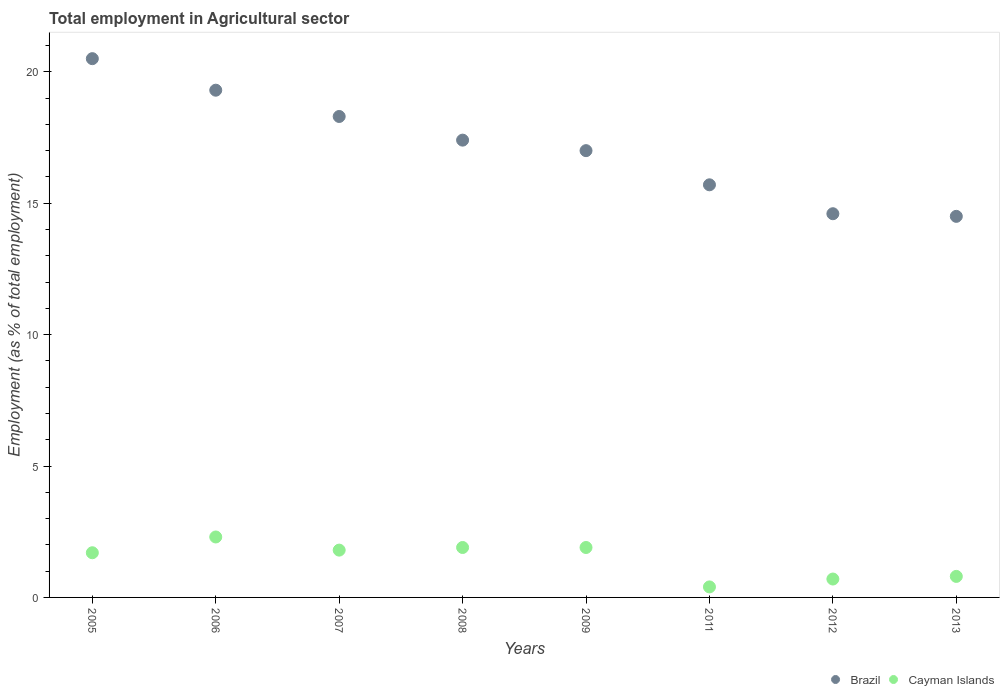How many different coloured dotlines are there?
Your answer should be very brief. 2. Is the number of dotlines equal to the number of legend labels?
Provide a short and direct response. Yes. What is the employment in agricultural sector in Cayman Islands in 2011?
Provide a short and direct response. 0.4. Across all years, what is the maximum employment in agricultural sector in Cayman Islands?
Your answer should be compact. 2.3. What is the total employment in agricultural sector in Brazil in the graph?
Give a very brief answer. 137.3. What is the difference between the employment in agricultural sector in Brazil in 2008 and that in 2013?
Provide a short and direct response. 2.9. What is the difference between the employment in agricultural sector in Cayman Islands in 2006 and the employment in agricultural sector in Brazil in 2008?
Offer a very short reply. -15.1. What is the average employment in agricultural sector in Brazil per year?
Make the answer very short. 17.16. In the year 2012, what is the difference between the employment in agricultural sector in Cayman Islands and employment in agricultural sector in Brazil?
Your answer should be very brief. -13.9. What is the ratio of the employment in agricultural sector in Brazil in 2005 to that in 2011?
Give a very brief answer. 1.31. Is the difference between the employment in agricultural sector in Cayman Islands in 2006 and 2007 greater than the difference between the employment in agricultural sector in Brazil in 2006 and 2007?
Your answer should be compact. No. What is the difference between the highest and the second highest employment in agricultural sector in Cayman Islands?
Ensure brevity in your answer.  0.4. What is the difference between the highest and the lowest employment in agricultural sector in Brazil?
Your response must be concise. 6. Is the sum of the employment in agricultural sector in Brazil in 2007 and 2011 greater than the maximum employment in agricultural sector in Cayman Islands across all years?
Your answer should be very brief. Yes. Does the employment in agricultural sector in Brazil monotonically increase over the years?
Provide a succinct answer. No. How many dotlines are there?
Your answer should be compact. 2. What is the difference between two consecutive major ticks on the Y-axis?
Keep it short and to the point. 5. Are the values on the major ticks of Y-axis written in scientific E-notation?
Give a very brief answer. No. Does the graph contain any zero values?
Your answer should be very brief. No. Where does the legend appear in the graph?
Provide a short and direct response. Bottom right. How many legend labels are there?
Make the answer very short. 2. What is the title of the graph?
Give a very brief answer. Total employment in Agricultural sector. What is the label or title of the X-axis?
Offer a very short reply. Years. What is the label or title of the Y-axis?
Keep it short and to the point. Employment (as % of total employment). What is the Employment (as % of total employment) in Brazil in 2005?
Your answer should be compact. 20.5. What is the Employment (as % of total employment) of Cayman Islands in 2005?
Provide a succinct answer. 1.7. What is the Employment (as % of total employment) in Brazil in 2006?
Offer a terse response. 19.3. What is the Employment (as % of total employment) of Cayman Islands in 2006?
Make the answer very short. 2.3. What is the Employment (as % of total employment) in Brazil in 2007?
Ensure brevity in your answer.  18.3. What is the Employment (as % of total employment) of Cayman Islands in 2007?
Make the answer very short. 1.8. What is the Employment (as % of total employment) of Brazil in 2008?
Your response must be concise. 17.4. What is the Employment (as % of total employment) in Cayman Islands in 2008?
Your answer should be very brief. 1.9. What is the Employment (as % of total employment) of Cayman Islands in 2009?
Your response must be concise. 1.9. What is the Employment (as % of total employment) of Brazil in 2011?
Provide a short and direct response. 15.7. What is the Employment (as % of total employment) of Cayman Islands in 2011?
Provide a succinct answer. 0.4. What is the Employment (as % of total employment) in Brazil in 2012?
Your response must be concise. 14.6. What is the Employment (as % of total employment) in Cayman Islands in 2012?
Give a very brief answer. 0.7. What is the Employment (as % of total employment) of Cayman Islands in 2013?
Your answer should be very brief. 0.8. Across all years, what is the maximum Employment (as % of total employment) in Brazil?
Give a very brief answer. 20.5. Across all years, what is the maximum Employment (as % of total employment) in Cayman Islands?
Provide a succinct answer. 2.3. Across all years, what is the minimum Employment (as % of total employment) in Brazil?
Provide a succinct answer. 14.5. Across all years, what is the minimum Employment (as % of total employment) of Cayman Islands?
Your response must be concise. 0.4. What is the total Employment (as % of total employment) in Brazil in the graph?
Ensure brevity in your answer.  137.3. What is the difference between the Employment (as % of total employment) of Brazil in 2005 and that in 2006?
Your response must be concise. 1.2. What is the difference between the Employment (as % of total employment) of Brazil in 2005 and that in 2008?
Your response must be concise. 3.1. What is the difference between the Employment (as % of total employment) of Cayman Islands in 2005 and that in 2008?
Provide a short and direct response. -0.2. What is the difference between the Employment (as % of total employment) in Cayman Islands in 2005 and that in 2009?
Keep it short and to the point. -0.2. What is the difference between the Employment (as % of total employment) in Brazil in 2005 and that in 2011?
Your answer should be compact. 4.8. What is the difference between the Employment (as % of total employment) of Brazil in 2005 and that in 2012?
Your answer should be very brief. 5.9. What is the difference between the Employment (as % of total employment) of Brazil in 2005 and that in 2013?
Give a very brief answer. 6. What is the difference between the Employment (as % of total employment) of Brazil in 2006 and that in 2007?
Keep it short and to the point. 1. What is the difference between the Employment (as % of total employment) of Cayman Islands in 2006 and that in 2007?
Provide a succinct answer. 0.5. What is the difference between the Employment (as % of total employment) of Brazil in 2006 and that in 2008?
Provide a short and direct response. 1.9. What is the difference between the Employment (as % of total employment) in Brazil in 2006 and that in 2009?
Ensure brevity in your answer.  2.3. What is the difference between the Employment (as % of total employment) of Cayman Islands in 2006 and that in 2009?
Provide a succinct answer. 0.4. What is the difference between the Employment (as % of total employment) of Brazil in 2006 and that in 2012?
Give a very brief answer. 4.7. What is the difference between the Employment (as % of total employment) in Cayman Islands in 2006 and that in 2012?
Your answer should be compact. 1.6. What is the difference between the Employment (as % of total employment) of Cayman Islands in 2006 and that in 2013?
Offer a terse response. 1.5. What is the difference between the Employment (as % of total employment) in Cayman Islands in 2007 and that in 2008?
Make the answer very short. -0.1. What is the difference between the Employment (as % of total employment) of Cayman Islands in 2007 and that in 2009?
Ensure brevity in your answer.  -0.1. What is the difference between the Employment (as % of total employment) in Cayman Islands in 2007 and that in 2011?
Provide a short and direct response. 1.4. What is the difference between the Employment (as % of total employment) of Brazil in 2007 and that in 2012?
Make the answer very short. 3.7. What is the difference between the Employment (as % of total employment) in Cayman Islands in 2007 and that in 2012?
Your answer should be compact. 1.1. What is the difference between the Employment (as % of total employment) in Brazil in 2007 and that in 2013?
Offer a very short reply. 3.8. What is the difference between the Employment (as % of total employment) in Cayman Islands in 2007 and that in 2013?
Offer a terse response. 1. What is the difference between the Employment (as % of total employment) in Brazil in 2008 and that in 2009?
Your response must be concise. 0.4. What is the difference between the Employment (as % of total employment) of Brazil in 2008 and that in 2013?
Offer a very short reply. 2.9. What is the difference between the Employment (as % of total employment) of Cayman Islands in 2008 and that in 2013?
Provide a succinct answer. 1.1. What is the difference between the Employment (as % of total employment) in Brazil in 2009 and that in 2011?
Keep it short and to the point. 1.3. What is the difference between the Employment (as % of total employment) of Brazil in 2009 and that in 2012?
Make the answer very short. 2.4. What is the difference between the Employment (as % of total employment) of Cayman Islands in 2009 and that in 2013?
Make the answer very short. 1.1. What is the difference between the Employment (as % of total employment) of Cayman Islands in 2011 and that in 2012?
Provide a short and direct response. -0.3. What is the difference between the Employment (as % of total employment) in Brazil in 2011 and that in 2013?
Provide a short and direct response. 1.2. What is the difference between the Employment (as % of total employment) of Brazil in 2005 and the Employment (as % of total employment) of Cayman Islands in 2008?
Your answer should be compact. 18.6. What is the difference between the Employment (as % of total employment) of Brazil in 2005 and the Employment (as % of total employment) of Cayman Islands in 2009?
Offer a terse response. 18.6. What is the difference between the Employment (as % of total employment) of Brazil in 2005 and the Employment (as % of total employment) of Cayman Islands in 2011?
Your answer should be compact. 20.1. What is the difference between the Employment (as % of total employment) of Brazil in 2005 and the Employment (as % of total employment) of Cayman Islands in 2012?
Your answer should be very brief. 19.8. What is the difference between the Employment (as % of total employment) in Brazil in 2005 and the Employment (as % of total employment) in Cayman Islands in 2013?
Your response must be concise. 19.7. What is the difference between the Employment (as % of total employment) of Brazil in 2006 and the Employment (as % of total employment) of Cayman Islands in 2007?
Offer a terse response. 17.5. What is the difference between the Employment (as % of total employment) of Brazil in 2006 and the Employment (as % of total employment) of Cayman Islands in 2008?
Your answer should be very brief. 17.4. What is the difference between the Employment (as % of total employment) of Brazil in 2006 and the Employment (as % of total employment) of Cayman Islands in 2011?
Make the answer very short. 18.9. What is the difference between the Employment (as % of total employment) in Brazil in 2006 and the Employment (as % of total employment) in Cayman Islands in 2013?
Ensure brevity in your answer.  18.5. What is the difference between the Employment (as % of total employment) of Brazil in 2007 and the Employment (as % of total employment) of Cayman Islands in 2008?
Offer a terse response. 16.4. What is the difference between the Employment (as % of total employment) in Brazil in 2007 and the Employment (as % of total employment) in Cayman Islands in 2009?
Keep it short and to the point. 16.4. What is the difference between the Employment (as % of total employment) in Brazil in 2007 and the Employment (as % of total employment) in Cayman Islands in 2012?
Provide a short and direct response. 17.6. What is the difference between the Employment (as % of total employment) in Brazil in 2007 and the Employment (as % of total employment) in Cayman Islands in 2013?
Your answer should be compact. 17.5. What is the difference between the Employment (as % of total employment) of Brazil in 2008 and the Employment (as % of total employment) of Cayman Islands in 2009?
Your response must be concise. 15.5. What is the difference between the Employment (as % of total employment) of Brazil in 2008 and the Employment (as % of total employment) of Cayman Islands in 2011?
Your response must be concise. 17. What is the average Employment (as % of total employment) of Brazil per year?
Your response must be concise. 17.16. What is the average Employment (as % of total employment) in Cayman Islands per year?
Provide a succinct answer. 1.44. In the year 2008, what is the difference between the Employment (as % of total employment) in Brazil and Employment (as % of total employment) in Cayman Islands?
Provide a succinct answer. 15.5. In the year 2009, what is the difference between the Employment (as % of total employment) in Brazil and Employment (as % of total employment) in Cayman Islands?
Provide a succinct answer. 15.1. What is the ratio of the Employment (as % of total employment) in Brazil in 2005 to that in 2006?
Keep it short and to the point. 1.06. What is the ratio of the Employment (as % of total employment) of Cayman Islands in 2005 to that in 2006?
Provide a succinct answer. 0.74. What is the ratio of the Employment (as % of total employment) of Brazil in 2005 to that in 2007?
Your answer should be very brief. 1.12. What is the ratio of the Employment (as % of total employment) in Brazil in 2005 to that in 2008?
Your answer should be very brief. 1.18. What is the ratio of the Employment (as % of total employment) of Cayman Islands in 2005 to that in 2008?
Your answer should be very brief. 0.89. What is the ratio of the Employment (as % of total employment) of Brazil in 2005 to that in 2009?
Make the answer very short. 1.21. What is the ratio of the Employment (as % of total employment) in Cayman Islands in 2005 to that in 2009?
Provide a succinct answer. 0.89. What is the ratio of the Employment (as % of total employment) of Brazil in 2005 to that in 2011?
Your answer should be compact. 1.31. What is the ratio of the Employment (as % of total employment) in Cayman Islands in 2005 to that in 2011?
Your answer should be compact. 4.25. What is the ratio of the Employment (as % of total employment) in Brazil in 2005 to that in 2012?
Keep it short and to the point. 1.4. What is the ratio of the Employment (as % of total employment) of Cayman Islands in 2005 to that in 2012?
Offer a terse response. 2.43. What is the ratio of the Employment (as % of total employment) of Brazil in 2005 to that in 2013?
Give a very brief answer. 1.41. What is the ratio of the Employment (as % of total employment) of Cayman Islands in 2005 to that in 2013?
Provide a succinct answer. 2.12. What is the ratio of the Employment (as % of total employment) of Brazil in 2006 to that in 2007?
Give a very brief answer. 1.05. What is the ratio of the Employment (as % of total employment) of Cayman Islands in 2006 to that in 2007?
Offer a very short reply. 1.28. What is the ratio of the Employment (as % of total employment) in Brazil in 2006 to that in 2008?
Your response must be concise. 1.11. What is the ratio of the Employment (as % of total employment) in Cayman Islands in 2006 to that in 2008?
Your answer should be compact. 1.21. What is the ratio of the Employment (as % of total employment) of Brazil in 2006 to that in 2009?
Your answer should be compact. 1.14. What is the ratio of the Employment (as % of total employment) in Cayman Islands in 2006 to that in 2009?
Provide a succinct answer. 1.21. What is the ratio of the Employment (as % of total employment) of Brazil in 2006 to that in 2011?
Your answer should be compact. 1.23. What is the ratio of the Employment (as % of total employment) in Cayman Islands in 2006 to that in 2011?
Make the answer very short. 5.75. What is the ratio of the Employment (as % of total employment) of Brazil in 2006 to that in 2012?
Offer a terse response. 1.32. What is the ratio of the Employment (as % of total employment) of Cayman Islands in 2006 to that in 2012?
Your answer should be very brief. 3.29. What is the ratio of the Employment (as % of total employment) of Brazil in 2006 to that in 2013?
Your answer should be compact. 1.33. What is the ratio of the Employment (as % of total employment) in Cayman Islands in 2006 to that in 2013?
Provide a short and direct response. 2.88. What is the ratio of the Employment (as % of total employment) in Brazil in 2007 to that in 2008?
Offer a very short reply. 1.05. What is the ratio of the Employment (as % of total employment) of Brazil in 2007 to that in 2009?
Offer a terse response. 1.08. What is the ratio of the Employment (as % of total employment) in Cayman Islands in 2007 to that in 2009?
Provide a succinct answer. 0.95. What is the ratio of the Employment (as % of total employment) of Brazil in 2007 to that in 2011?
Make the answer very short. 1.17. What is the ratio of the Employment (as % of total employment) in Cayman Islands in 2007 to that in 2011?
Provide a succinct answer. 4.5. What is the ratio of the Employment (as % of total employment) in Brazil in 2007 to that in 2012?
Your response must be concise. 1.25. What is the ratio of the Employment (as % of total employment) in Cayman Islands in 2007 to that in 2012?
Your answer should be compact. 2.57. What is the ratio of the Employment (as % of total employment) in Brazil in 2007 to that in 2013?
Give a very brief answer. 1.26. What is the ratio of the Employment (as % of total employment) in Cayman Islands in 2007 to that in 2013?
Keep it short and to the point. 2.25. What is the ratio of the Employment (as % of total employment) in Brazil in 2008 to that in 2009?
Offer a very short reply. 1.02. What is the ratio of the Employment (as % of total employment) of Brazil in 2008 to that in 2011?
Provide a short and direct response. 1.11. What is the ratio of the Employment (as % of total employment) of Cayman Islands in 2008 to that in 2011?
Your answer should be very brief. 4.75. What is the ratio of the Employment (as % of total employment) of Brazil in 2008 to that in 2012?
Your answer should be compact. 1.19. What is the ratio of the Employment (as % of total employment) of Cayman Islands in 2008 to that in 2012?
Provide a succinct answer. 2.71. What is the ratio of the Employment (as % of total employment) of Cayman Islands in 2008 to that in 2013?
Ensure brevity in your answer.  2.38. What is the ratio of the Employment (as % of total employment) of Brazil in 2009 to that in 2011?
Your answer should be very brief. 1.08. What is the ratio of the Employment (as % of total employment) in Cayman Islands in 2009 to that in 2011?
Your response must be concise. 4.75. What is the ratio of the Employment (as % of total employment) of Brazil in 2009 to that in 2012?
Offer a very short reply. 1.16. What is the ratio of the Employment (as % of total employment) of Cayman Islands in 2009 to that in 2012?
Make the answer very short. 2.71. What is the ratio of the Employment (as % of total employment) of Brazil in 2009 to that in 2013?
Provide a short and direct response. 1.17. What is the ratio of the Employment (as % of total employment) of Cayman Islands in 2009 to that in 2013?
Your answer should be compact. 2.38. What is the ratio of the Employment (as % of total employment) of Brazil in 2011 to that in 2012?
Provide a succinct answer. 1.08. What is the ratio of the Employment (as % of total employment) of Brazil in 2011 to that in 2013?
Offer a terse response. 1.08. What is the ratio of the Employment (as % of total employment) of Cayman Islands in 2011 to that in 2013?
Provide a succinct answer. 0.5. What is the ratio of the Employment (as % of total employment) of Brazil in 2012 to that in 2013?
Your response must be concise. 1.01. What is the ratio of the Employment (as % of total employment) of Cayman Islands in 2012 to that in 2013?
Make the answer very short. 0.88. What is the difference between the highest and the second highest Employment (as % of total employment) of Brazil?
Your answer should be compact. 1.2. What is the difference between the highest and the lowest Employment (as % of total employment) of Brazil?
Ensure brevity in your answer.  6. What is the difference between the highest and the lowest Employment (as % of total employment) of Cayman Islands?
Your answer should be compact. 1.9. 